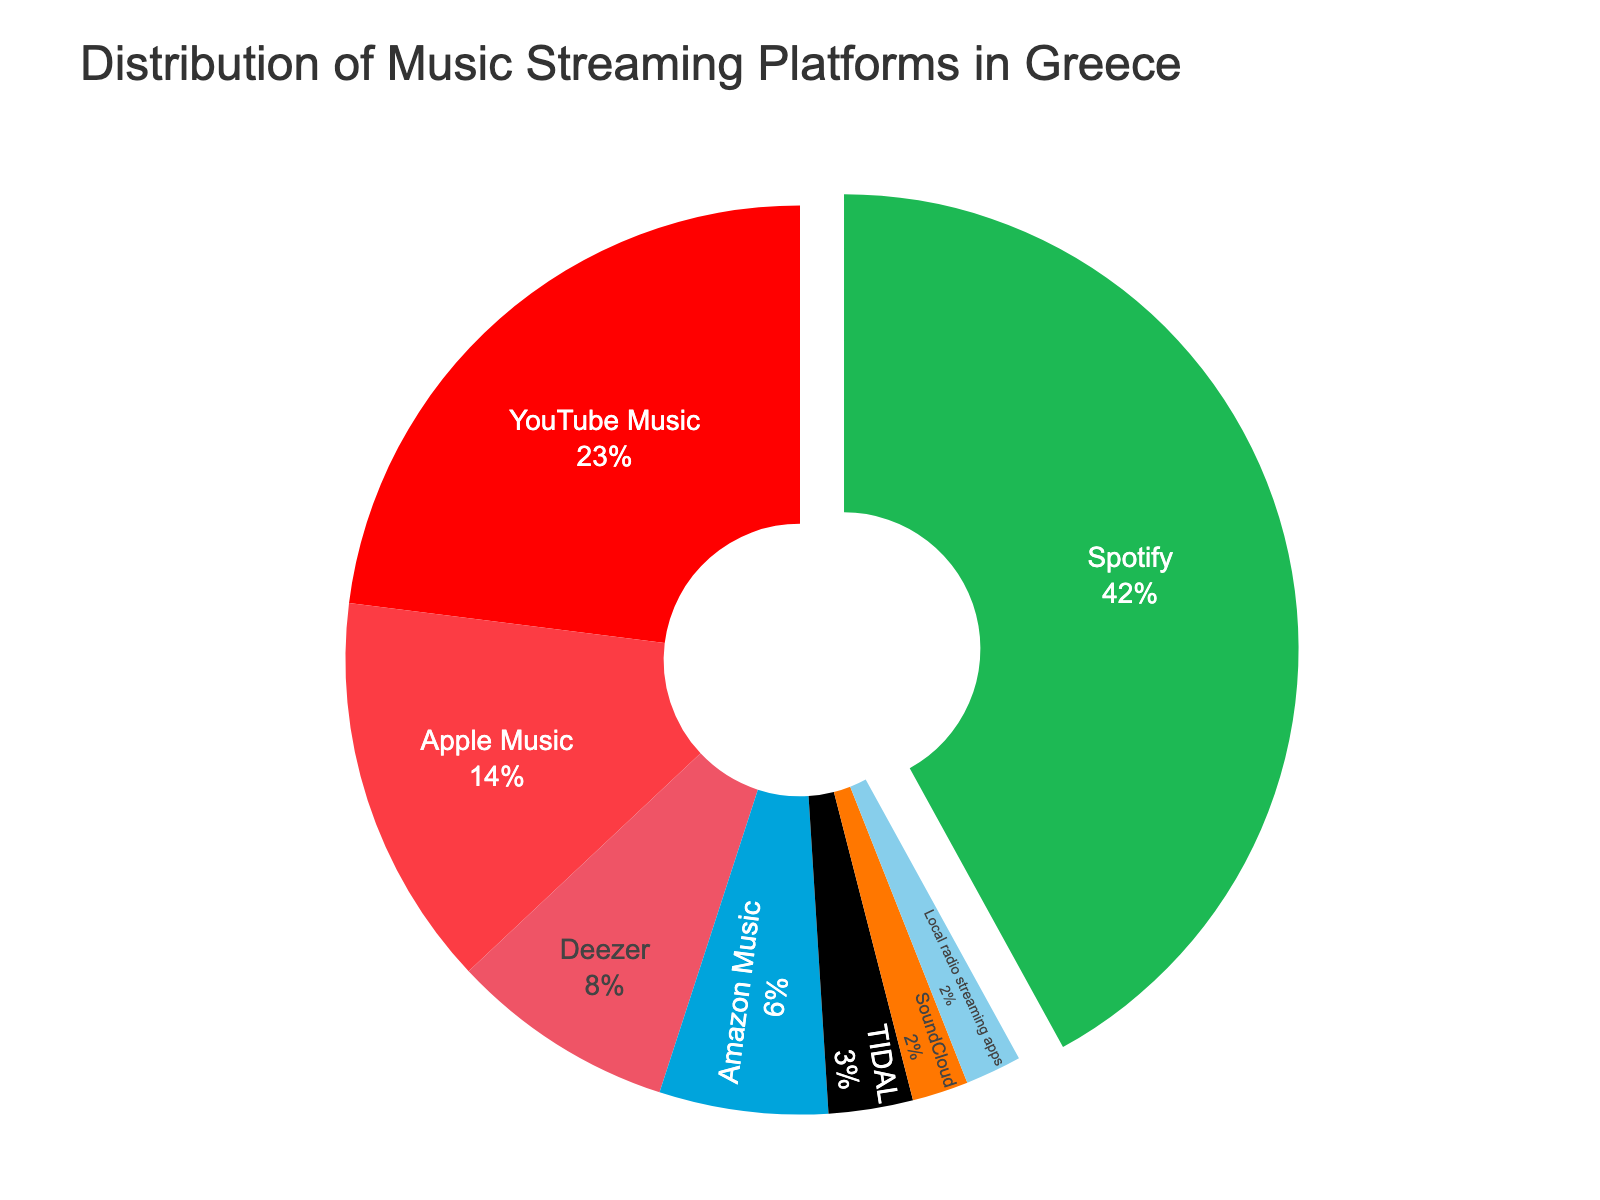Which platform has the highest percentage? The figure shows a pie chart with different music streaming platforms and their respective percentages. The highest percentage segment is for Spotify.
Answer: Spotify Which platforms have a percentage less than Deezer? The pie chart indicates Deezer has an 8% share. Platforms with less than 8% are Amazon Music, TIDAL, SoundCloud, and Local radio streaming apps.
Answer: Amazon Music, TIDAL, SoundCloud, Local radio streaming apps What is the combined percentage of YouTube Music and Apple Music? From the pie chart, YouTube Music has 23% and Apple Music has 14%. Adding them together gives 23% + 14% = 37%.
Answer: 37% How much more popular is Spotify compared to TIDAL? The pie chart shows Spotify at 42% and TIDAL at 3%. The difference is 42% - 3% = 39%.
Answer: 39% Which platform ranks third in terms of percentage? The chart displays the segments for each platform. The third largest segment is Apple Music with 14%.
Answer: Apple Music What is the total percentage represented by platforms other than Spotify? Spotify is 42%, so the remaining percentage is 100% - 42% = 58%.
Answer: 58% How does the percentage of Deezer compare to Amazon Music? Deezer is shown at 8% and Amazon Music at 6% in the pie chart. 8% is greater than 6%.
Answer: Deezer > Amazon Music If you combine the smallest three percentages, what do you get? The smallest three percentages are TIDAL (3%), SoundCloud (2%), and Local radio streaming apps (2%). Adding them together gives 3% + 2% + 2% = 7%.
Answer: 7% What color is associated with YouTube Music on the chart? The chart uses specific colors for each platform. YouTube Music is depicted in red.
Answer: Red 